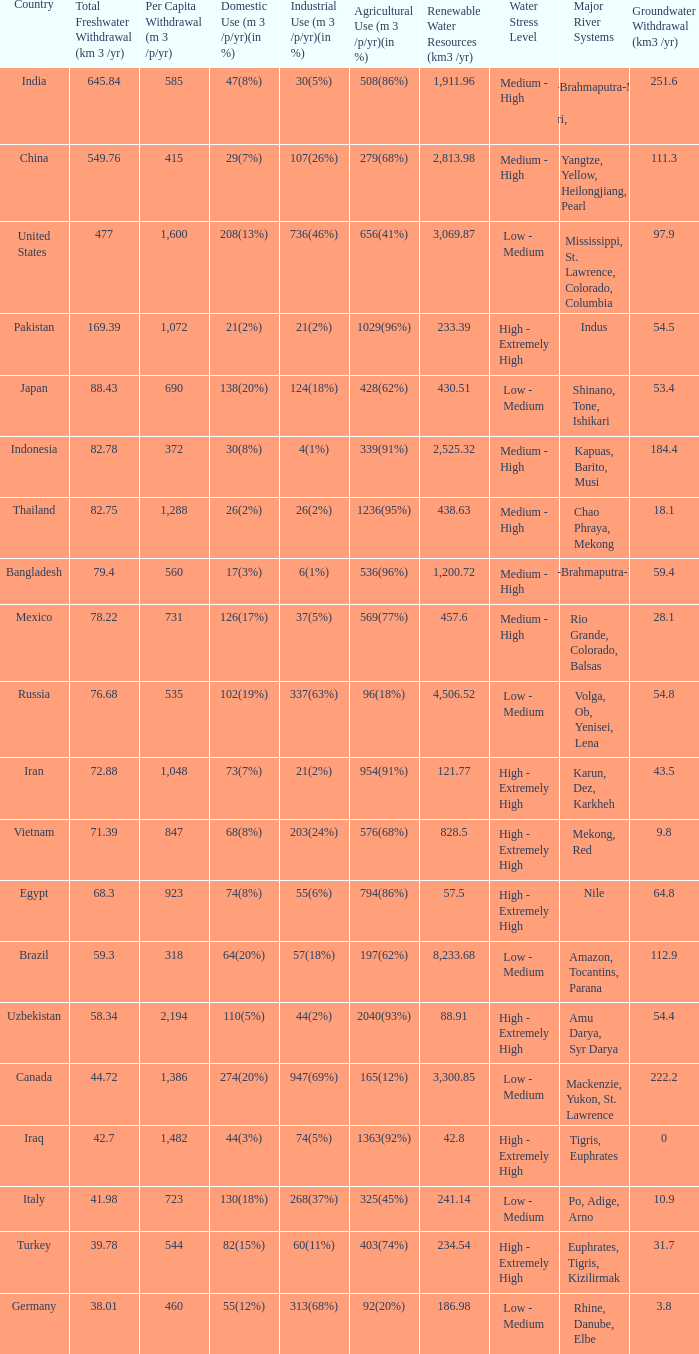What is Industrial Use (m 3 /p/yr)(in %), when Total Freshwater Withdrawal (km 3/yr) is less than 82.75, and when Agricultural Use (m 3 /p/yr)(in %) is 1363(92%)? 74(5%). 